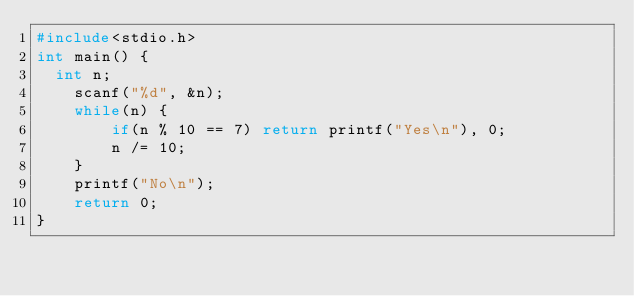<code> <loc_0><loc_0><loc_500><loc_500><_C_>#include<stdio.h>
int main() {
	int n;
    scanf("%d", &n);
    while(n) {
        if(n % 10 == 7) return printf("Yes\n"), 0;
        n /= 10;
    }
    printf("No\n");
    return 0;
}</code> 